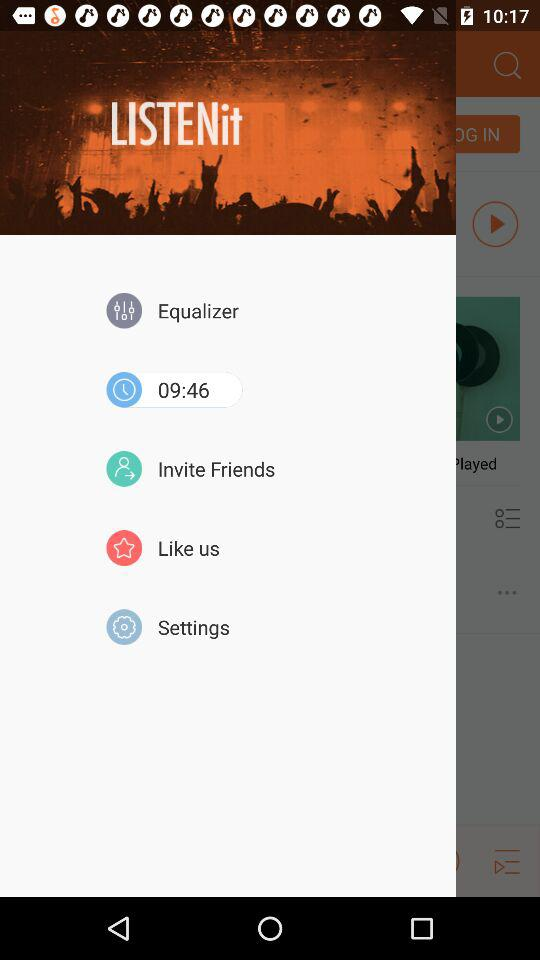What is the name of the application? The name of the application is "LISTENit". 